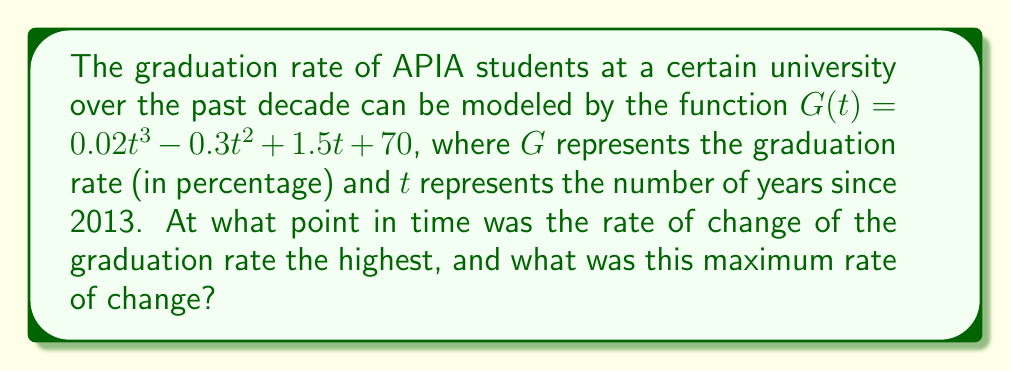Show me your answer to this math problem. To solve this problem, we need to follow these steps:

1) First, we need to find the rate of change of the graduation rate. This is given by the first derivative of $G(t)$:

   $G'(t) = 0.06t^2 - 0.6t + 1.5$

2) To find the maximum rate of change, we need to find where the second derivative equals zero:

   $G''(t) = 0.12t - 0.6$

3) Set $G''(t) = 0$ and solve for $t$:

   $0.12t - 0.6 = 0$
   $0.12t = 0.6$
   $t = 5$

4) This critical point ($t = 5$) corresponds to the year 2018 (5 years after 2013).

5) To confirm this is a maximum (not a minimum), we can check the sign of $G'''(t)$:

   $G'''(t) = 0.12$ (positive)

   Since $G'''(t)$ is positive, the critical point is indeed a maximum.

6) To find the maximum rate of change, we plug $t = 5$ into $G'(t)$:

   $G'(5) = 0.06(5^2) - 0.6(5) + 1.5$
          $= 1.5 - 3 + 1.5$
          $= 0$

Therefore, the maximum rate of change occurred in 2018 and was 0% per year.
Answer: 2018; 0% per year 